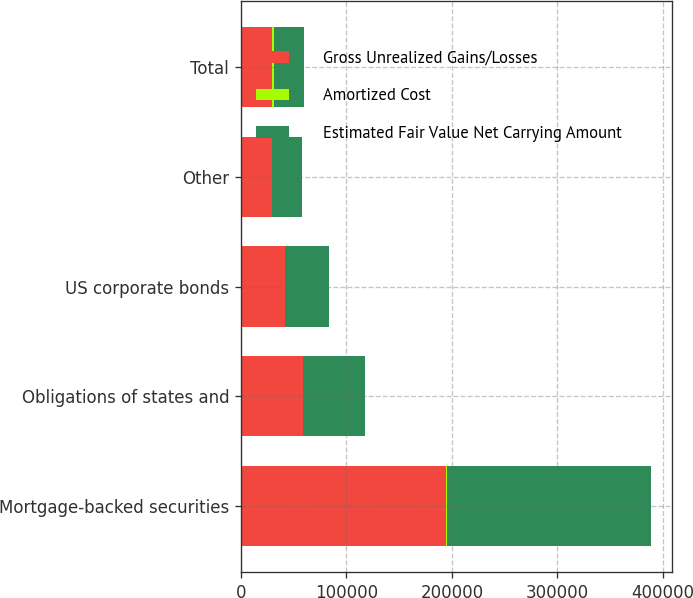Convert chart to OTSL. <chart><loc_0><loc_0><loc_500><loc_500><stacked_bar_chart><ecel><fcel>Mortgage-backed securities<fcel>Obligations of states and<fcel>US corporate bonds<fcel>Other<fcel>Total<nl><fcel>Gross Unrealized Gains/Losses<fcel>194422<fcel>58764<fcel>41861<fcel>29077<fcel>29077<nl><fcel>Amortized Cost<fcel>1237<fcel>409<fcel>260<fcel>3<fcel>1909<nl><fcel>Estimated Fair Value Net Carrying Amount<fcel>193185<fcel>58355<fcel>41601<fcel>29074<fcel>29077<nl></chart> 